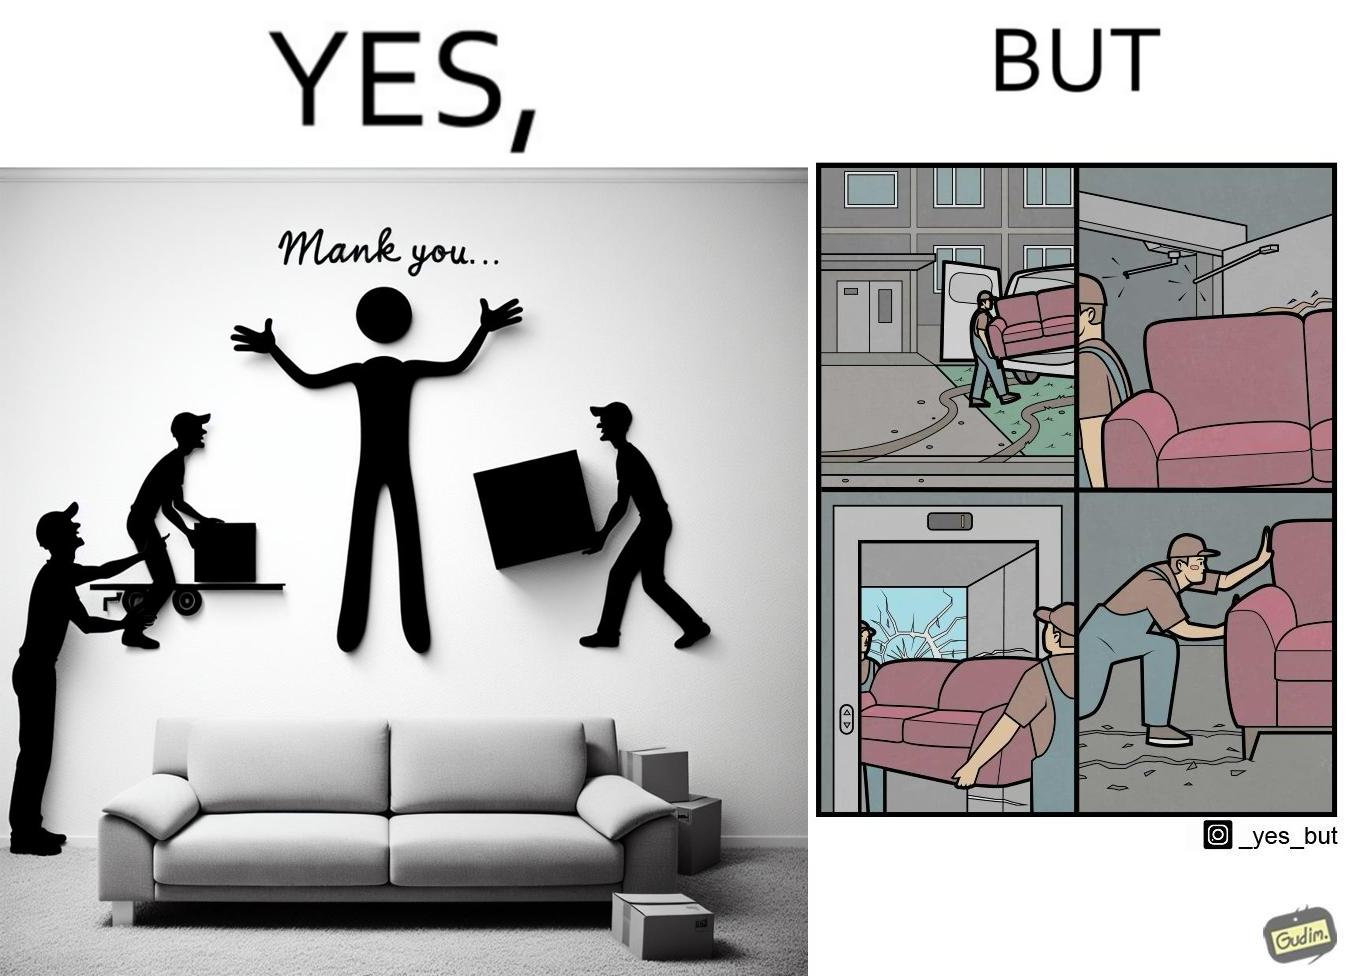What is the satirical meaning behind this image? The images are funny since they show how even though the hired movers achieve their task of moving in furniture, in the process, the cause damage to the whole house 